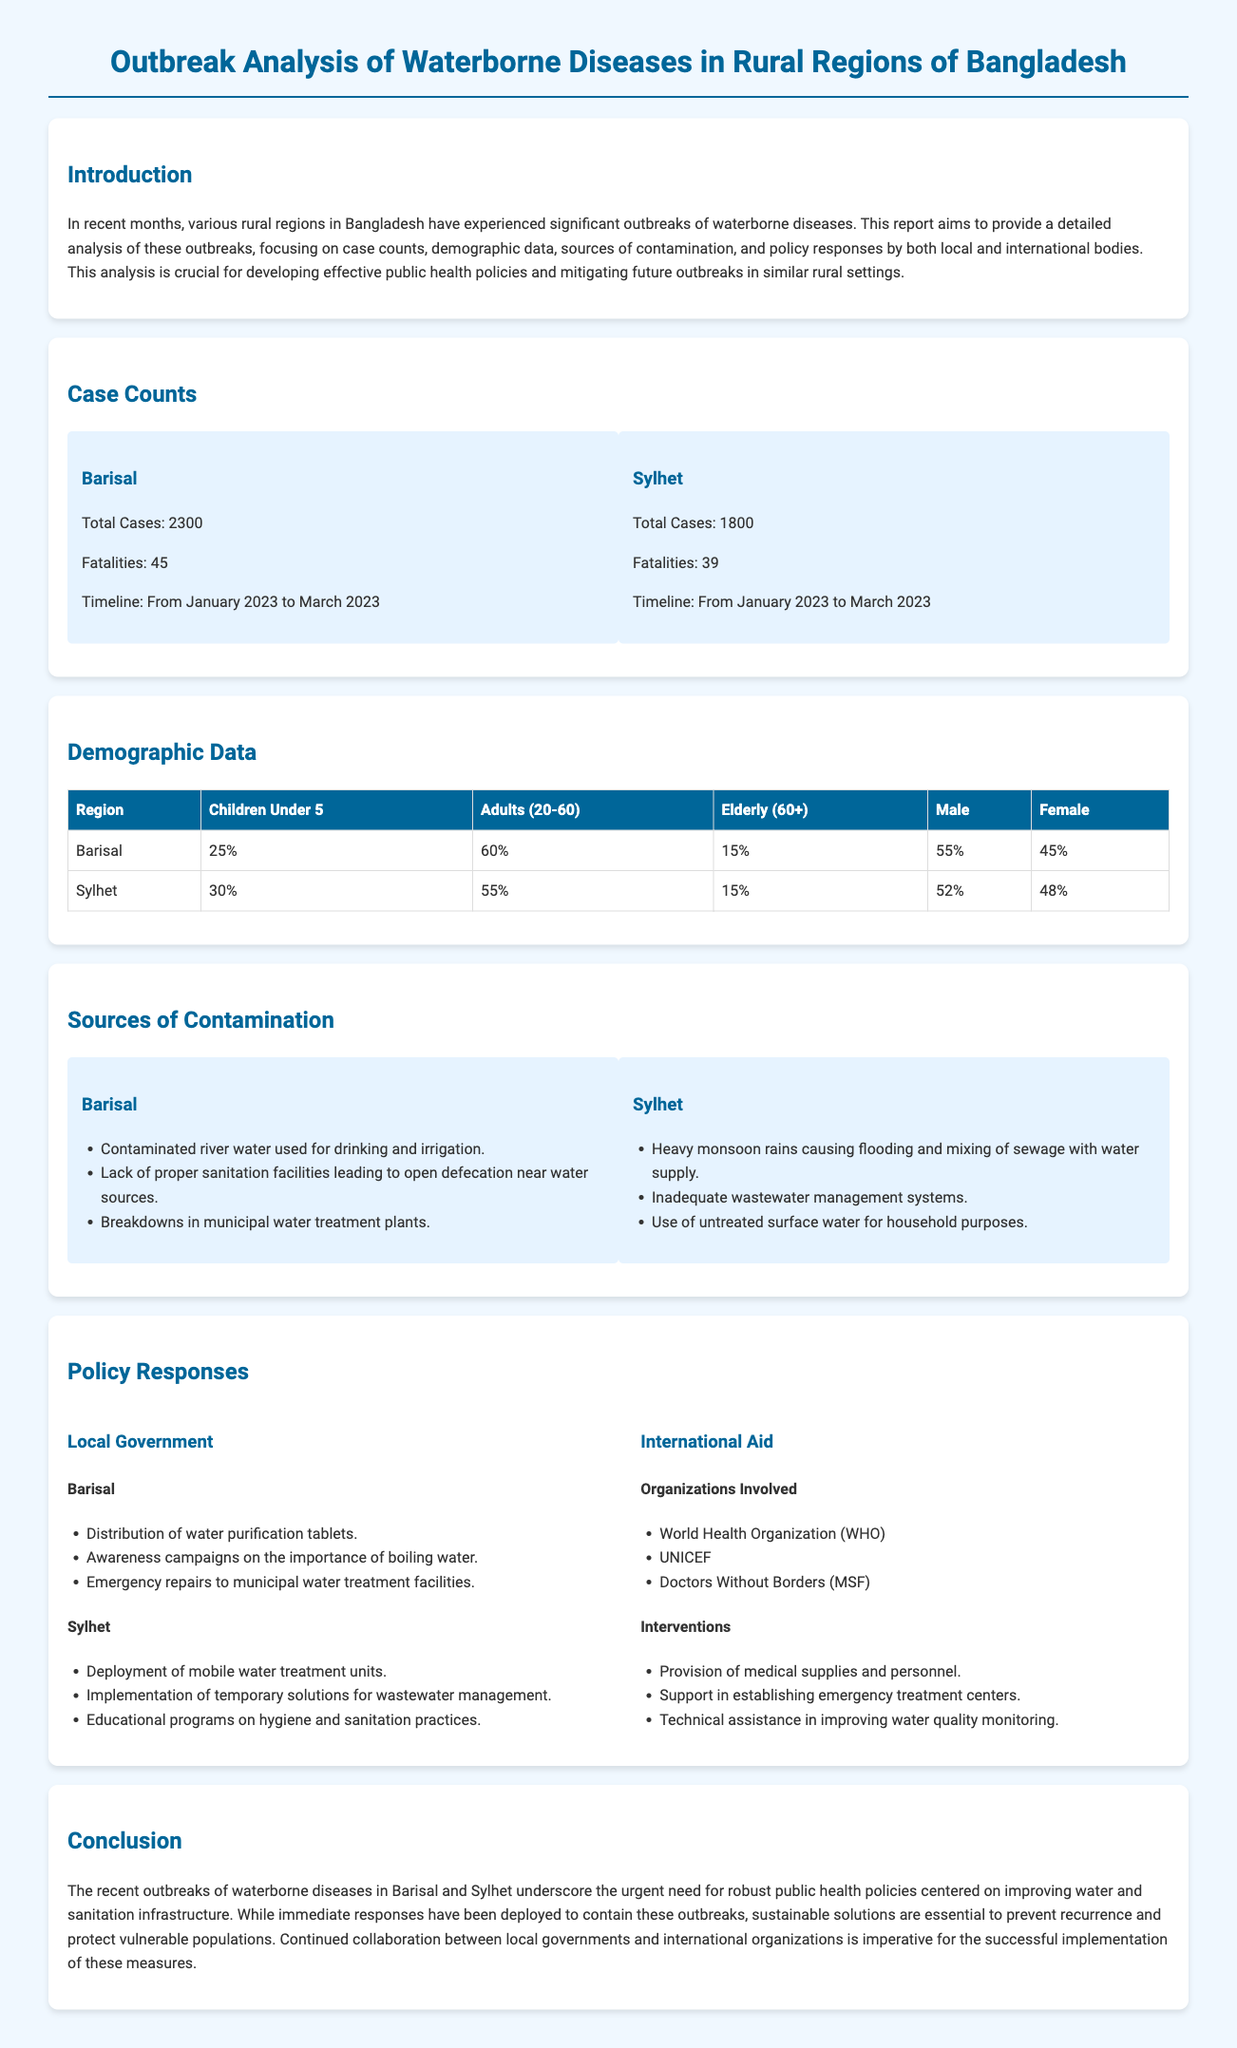what was the total number of cases in Barisal? The total number of cases is stated in the "Case Counts" section for Barisal.
Answer: 2300 what percentage of the population in Sylhet is children under 5? The percentage of children under 5 in Sylhet is specifically mentioned in the "Demographic Data" table.
Answer: 30% who were the organizations involved in international aid? The organizations providing international aid are listed in the "Policy Responses" section.
Answer: World Health Organization, UNICEF, Doctors Without Borders what was one source of contamination in Barisal? One source of contamination is indicated in the "Sources of Contamination" section for Barisal.
Answer: Contaminated river water used for drinking and irrigation how many fatalities were reported in Sylhet? The document lists the number of fatalities for Sylhet in the "Case Counts" section.
Answer: 39 what intervention was implemented by the local government in Barisal? An intervention by the local government in Barisal is outlined in the "Policy Responses" section.
Answer: Distribution of water purification tablets what was the timeline for the outbreaks in both Barisal and Sylhet? The timeline for the outbreaks in both regions is provided in the "Case Counts" section.
Answer: From January 2023 to March 2023 how many elderly (60+) were reported in Barisal? The percentage of elderly in Barisal can be found in the "Demographic Data" table.
Answer: 15% 